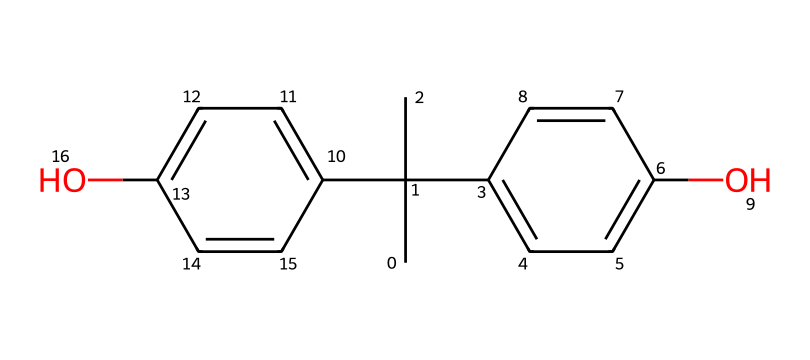What is the molecular formula of bisphenol A? The given SMILES representation can be analyzed to identify the elements and their counts. Upon breaking down the structure, we observe that there are 15 carbon (C) atoms, 16 hydrogen (H) atoms, and 2 oxygen (O) atoms, leading to the molecular formula C15H16O2.
Answer: C15H16O2 How many hydroxyl (-OH) groups are present in bisphenol A? From the chemical structure indicated in the SMILES representation, you can see that there are two -OH groups attached to the aromatic rings in bisphenol A. Hence, the count is directly observable from the structure.
Answer: 2 What type of chemical compound is bisphenol A? Analyzing the structure, bisphenol A has multiple phenolic groups (due to the hydroxyl groups and aromatic rings). Therefore, it is classified as a phenol derivative, commonly known for its role in plastic production.
Answer: phenol How many double bonds are present in bisphenol A? By examining the structure indicated in the SMILES, we note that there are six double bonds present within the benzene rings. Each of the rings has three double bonds. Therefore, counting these gives a total of six double bonds.
Answer: 6 What is the significance of the molecular structure of bisphenol A in relation to human health? The structure of bisphenol A is significant because it resembles estrogen, allowing it to bind to estrogen receptors, which can disrupt hormonal functions in humans. This structural similarity is the reason behind its potential endocrine-disrupting effects.
Answer: endocrine disruptor What is the primary use of bisphenol A? Considering its chemical structure and properties, bisphenol A is primarily used for manufacturing polycarbonate plastics and epoxy resins due to its ability to produce durable materials.
Answer: manufacturing plastics 